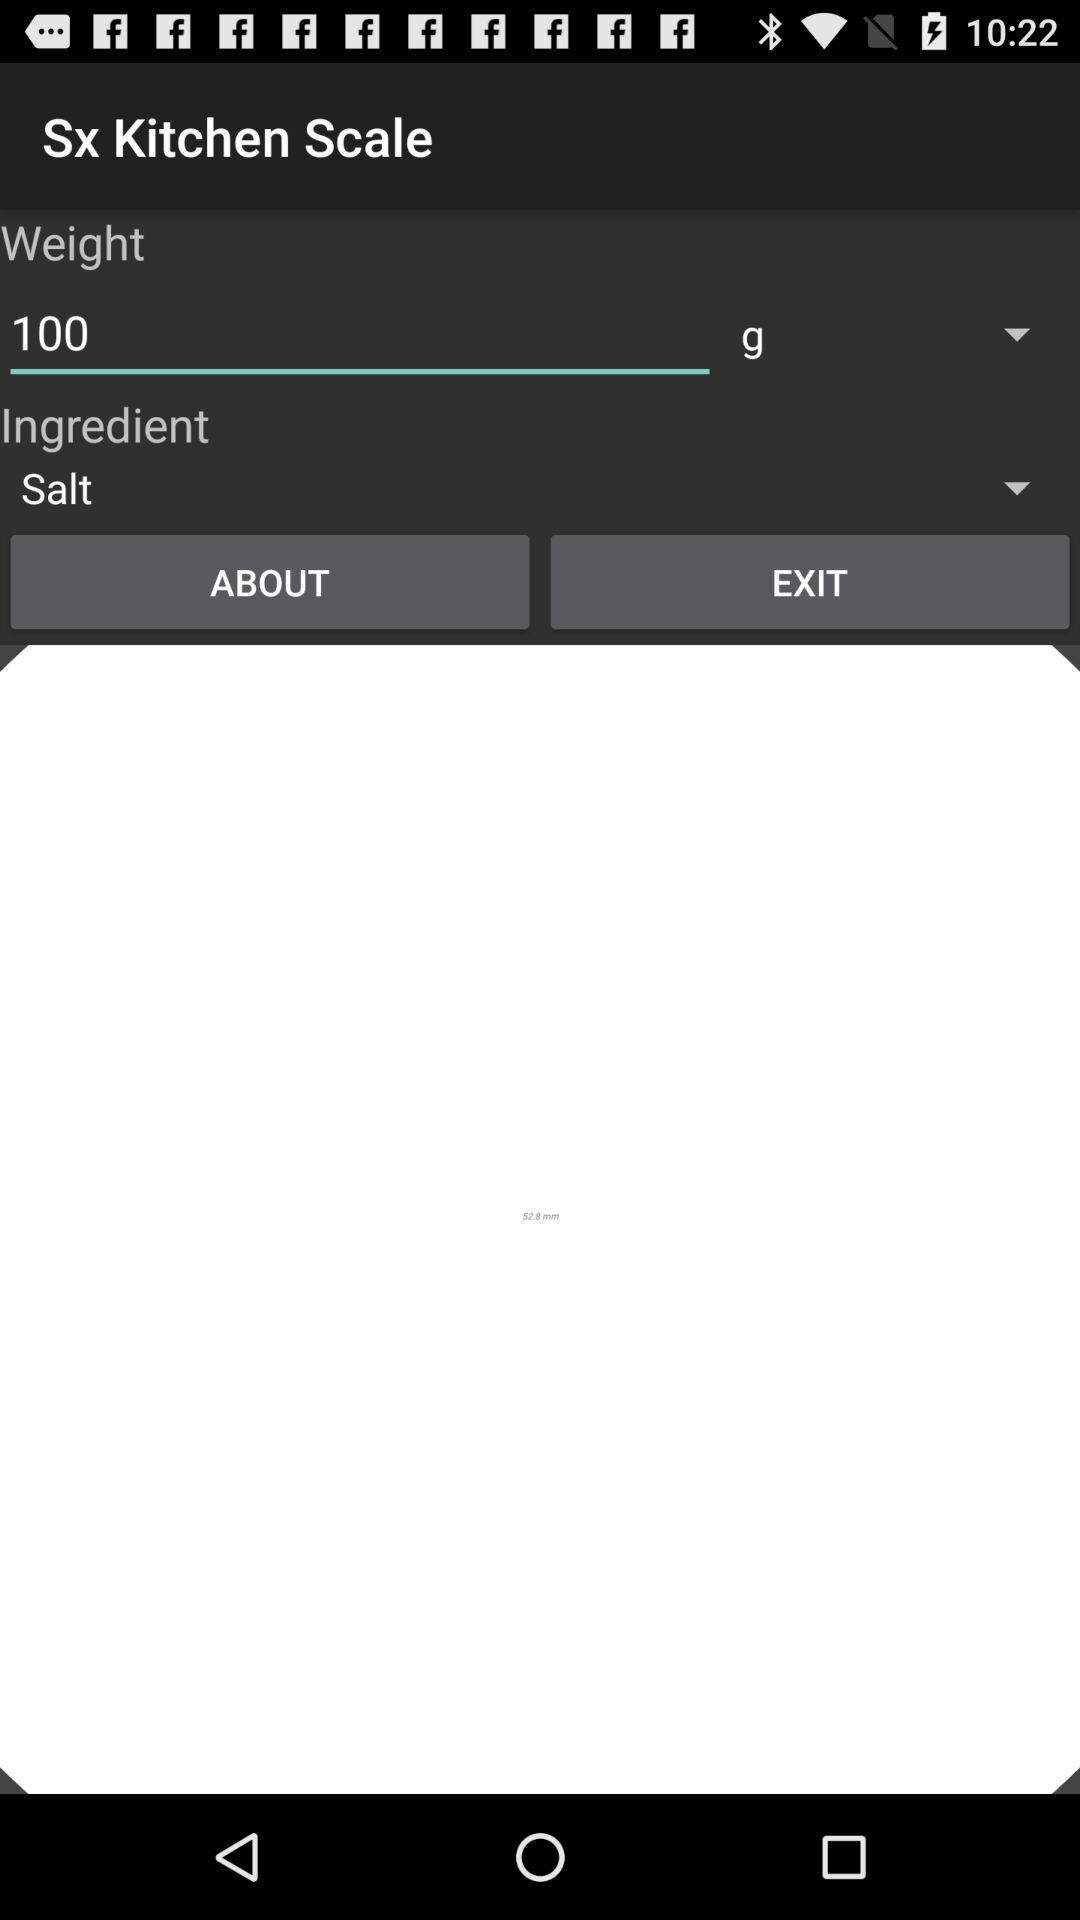What is the number of grams of salt that are being weighed?
Answer the question using a single word or phrase. 100 